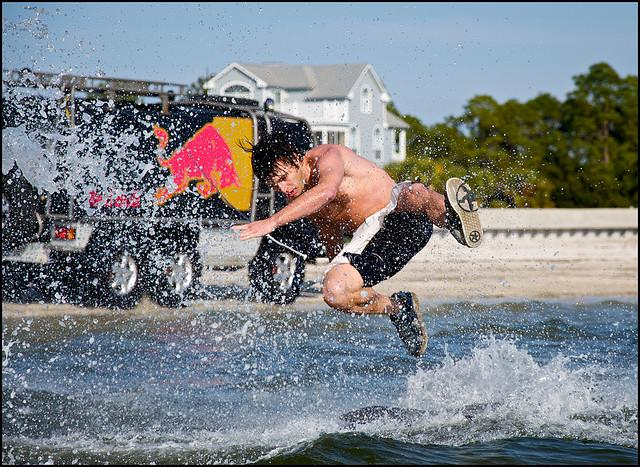What animal is the picture on the truck of? Please explain your reasoning. bull. It is a large bovine with horns on the head 